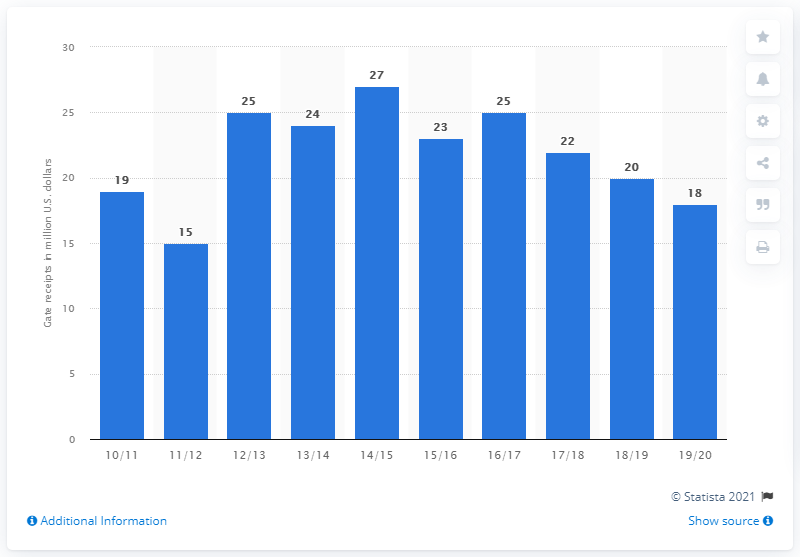Identify some key points in this picture. The gate receipts of the Memphis Grizzlies in the 2019/20 season were 18 dollars. 